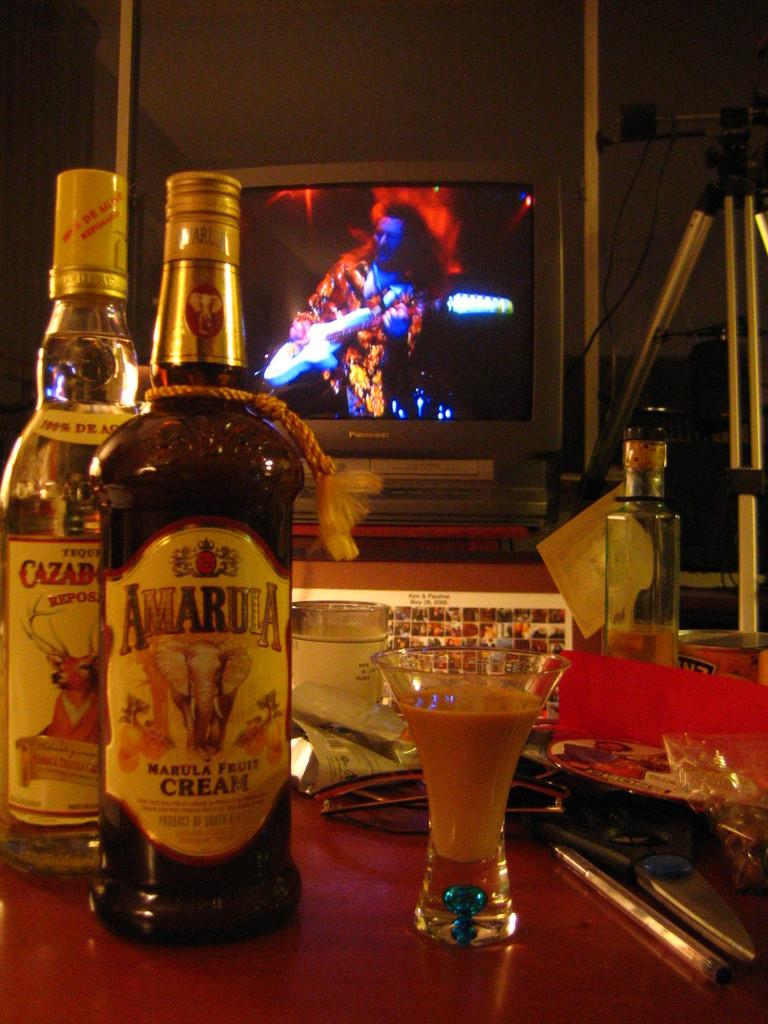What objects are present on the table in the image? There are bottles, glasses, scissors, a pen, and spectacles on the table in the image. Can you describe any other objects in the image? In the background, there is a television and a tripod stand. What might be used for cutting in the image? The scissors on the table can be used for cutting. What might be used for writing in the image? The pen on the table can be used for writing. What type of straw is being used to clean the laborer's boots in the image? There is no laborer or straw present in the image. 